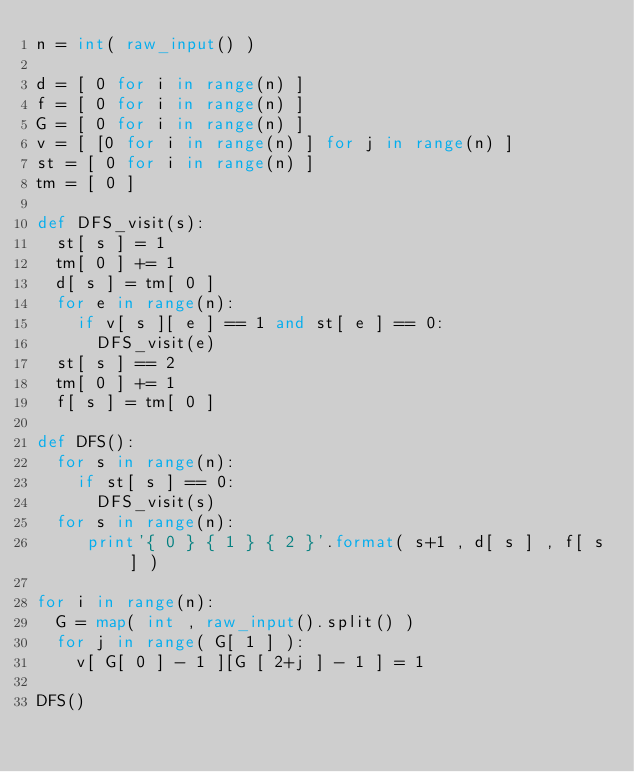<code> <loc_0><loc_0><loc_500><loc_500><_Python_>n = int( raw_input() )
   
d = [ 0 for i in range(n) ]
f = [ 0 for i in range(n) ]
G = [ 0 for i in range(n) ]
v = [ [0 for i in range(n) ] for j in range(n) ]
st = [ 0 for i in range(n) ]
tm = [ 0 ]
   
def DFS_visit(s):
  st[ s ] = 1
  tm[ 0 ] += 1
  d[ s ] = tm[ 0 ]
  for e in range(n):
    if v[ s ][ e ] == 1 and st[ e ] == 0:
      DFS_visit(e)
  st[ s ] == 2
  tm[ 0 ] += 1
  f[ s ] = tm[ 0 ]
   
def DFS():
  for s in range(n):
    if st[ s ] == 0:
      DFS_visit(s)
  for s in range(n):
     print'{ 0 } { 1 } { 2 }'.format( s+1 , d[ s ] , f[ s ] )
       
for i in range(n):
  G = map( int , raw_input().split() )
  for j in range( G[ 1 ] ):
    v[ G[ 0 ] - 1 ][G [ 2+j ] - 1 ] = 1
   
DFS()</code> 